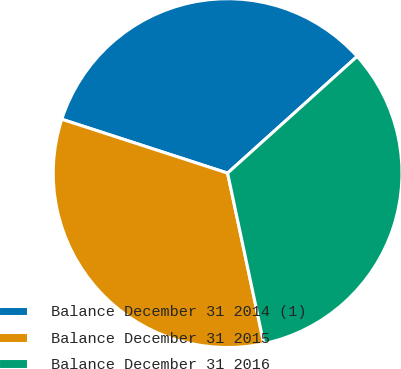Convert chart. <chart><loc_0><loc_0><loc_500><loc_500><pie_chart><fcel>Balance December 31 2014 (1)<fcel>Balance December 31 2015<fcel>Balance December 31 2016<nl><fcel>33.33%<fcel>33.33%<fcel>33.34%<nl></chart> 